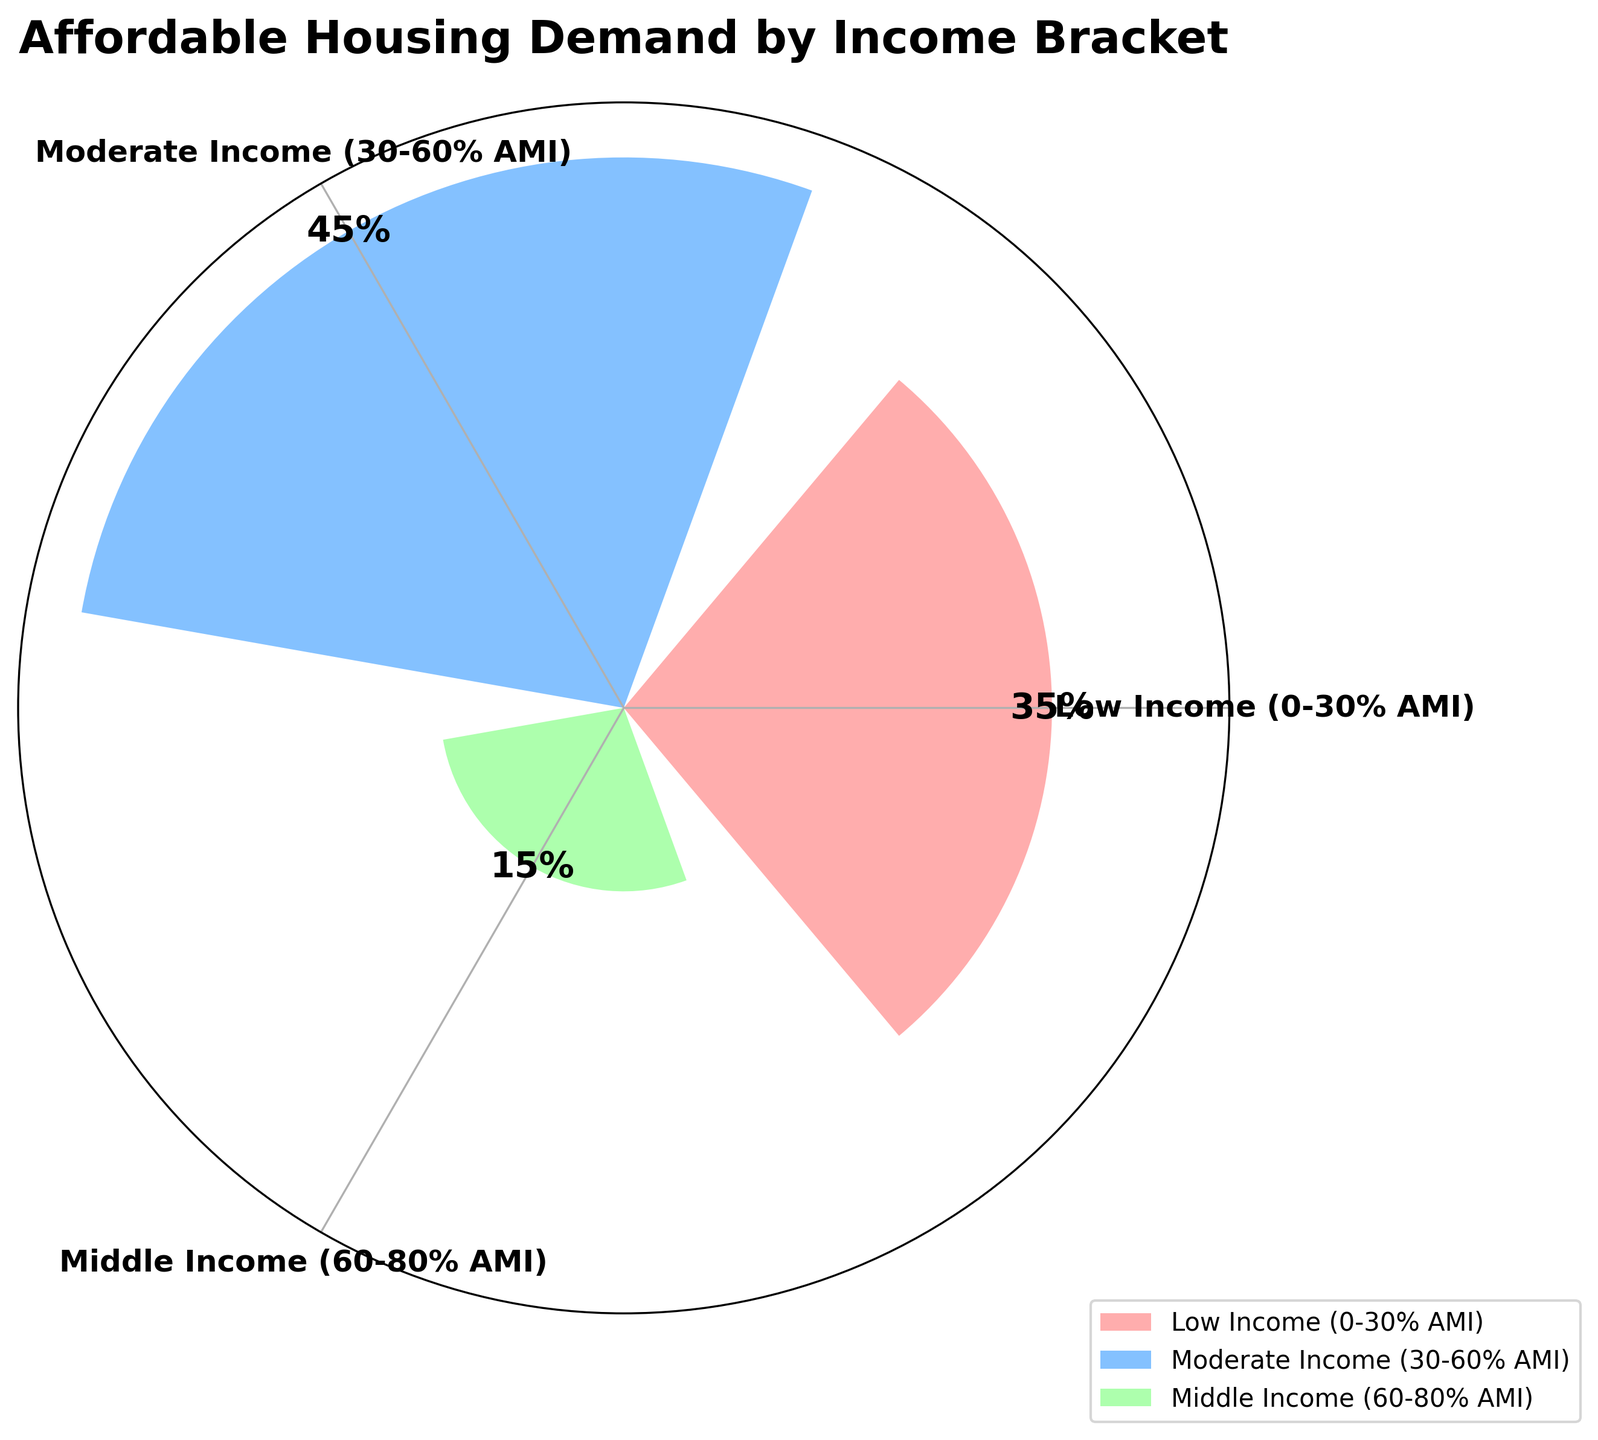What is the title of the figure? The title is usually positioned at the top of the figure and provides an overview of what the chart represents. In this case, the title is prominently displayed and clearly indicates the topic.
Answer: Affordable Housing Demand by Income Bracket Which income bracket has the highest demand percentage? The size of each sector in the rose chart corresponds to the demand percentage. The income bracket with the largest sector has the highest demand.
Answer: Moderate Income (30-60% AMI) What is the demand percentage for the Middle Income bracket? Look at the sector labeled "Middle Income (60-80% AMI)" and read the percentage displayed.
Answer: 15% What is the sum of the demand percentages for Low Income and Moderate Income brackets? Identify the percentages for these two brackets (35% for Low Income, 45% for Moderate Income) and add them together.
Answer: 80% Which income bracket has the smallest demand percentage? The income bracket with the smallest sector represents the smallest demand percentage. Among the displayed sectors, the "Upper-Middle Income (80-120% AMI)" bracket has the smallest percentage.
Answer: Upper-Middle Income (80-120% AMI) How much greater is the demand percentage for the Low Income bracket compared to the Middle Income bracket? Extract the percentages for both brackets (35% for Low Income, 15% for Middle Income) and subtract the latter from the former.
Answer: 20% Is the demand for Moderate Income bracket greater than the combined demand for Middle Income and Upper-Middle Income brackets? Calculate the combined percentage for Middle Income and Upper-Middle Income (15% + 5% = 20%) and compare it with the Moderate Income percentage (45%).
Answer: Yes What are the colors used for the different income brackets? Observe the colors of the sectors corresponding to the different income brackets. The colors used are shades of red, blue, and green.
Answer: Red, Blue, Green What is the average demand percentage for the three displayed income brackets? Add the percentages of the three income brackets (35%, 45%, 15%) and divide by 3 to get the average. \( \frac{35 + 45 + 15}{3} = 31.67 \)
Answer: 31.67% What type of chart is used to display the data in this figure? This type of chart displays data in a circular format, and sectors are used to represent different categories. This is known as a rose chart or polar area chart.
Answer: Rose chart 